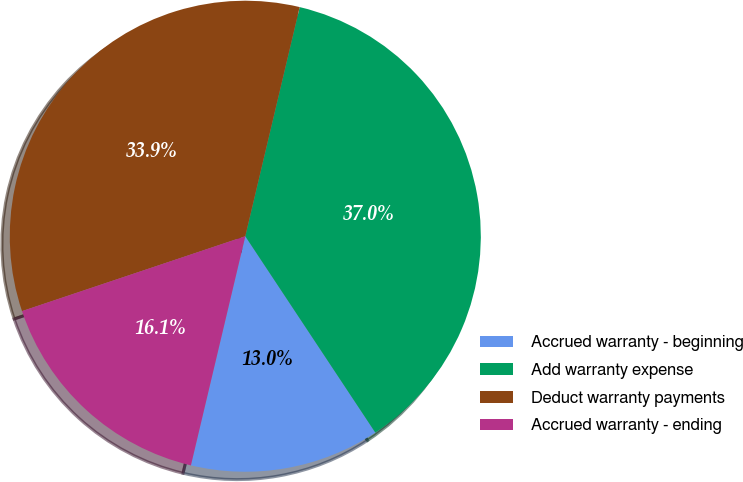<chart> <loc_0><loc_0><loc_500><loc_500><pie_chart><fcel>Accrued warranty - beginning<fcel>Add warranty expense<fcel>Deduct warranty payments<fcel>Accrued warranty - ending<nl><fcel>13.02%<fcel>36.98%<fcel>33.86%<fcel>16.14%<nl></chart> 